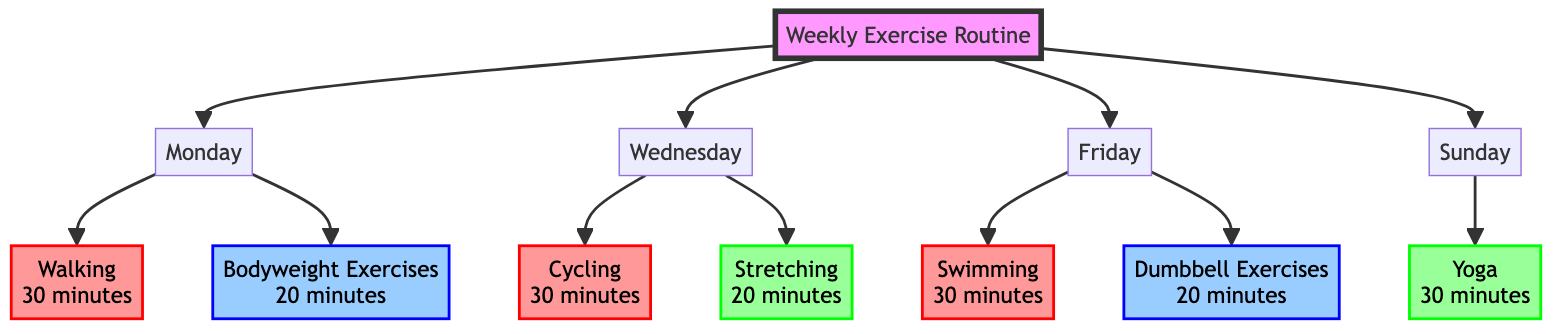What activities are scheduled on Monday? The diagram shows that on Monday, the activities include "Walking" for 30 minutes and "Bodyweight Exercises" for 20 minutes. These activities are connected directly to the Monday node.
Answer: Walking, Bodyweight Exercises How many minutes are allocated for cardio activities throughout the week? The cardio activities include "Walking" (30 minutes), "Cycling" (30 minutes), and "Swimming" (30 minutes), totaling 90 minutes. This can be calculated by adding the durations of each cardio activity in the diagram.
Answer: 90 minutes Which day has a flexibility exercise? The diagram indicates that flexibility exercises are scheduled on Wednesday ("Stretching") and Sunday ("Yoga"). The question asks for the day with at least one flexibility exercise, which includes both days when observed.
Answer: Wednesday, Sunday What type of exercise is performed on Friday? On Friday, the diagram specifies two types of exercises: "Swimming" as a cardio activity and "Dumbbell Exercises" as a strength training activity. The question focuses on identifying the types of exercises on that day.
Answer: Cardio, Strength Training Which activity is the only one scheduled on Sunday? The diagram shows that on Sunday, the only activity listed is "Yoga" for 30 minutes. This is seen directly under the Sunday node, indicating that it is the sole exercise planned for that day.
Answer: Yoga 